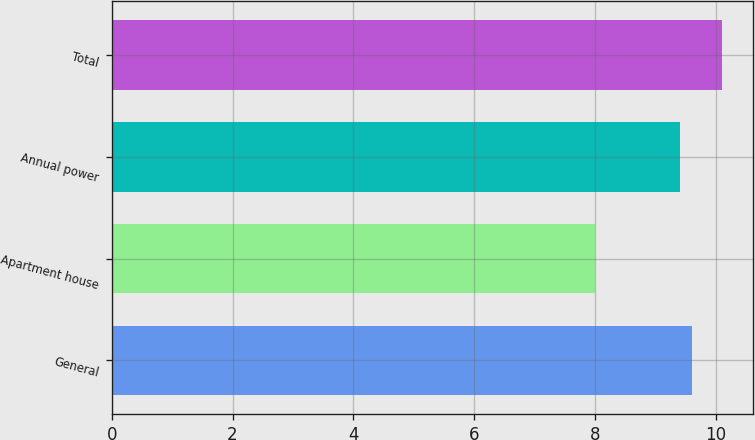Convert chart. <chart><loc_0><loc_0><loc_500><loc_500><bar_chart><fcel>General<fcel>Apartment house<fcel>Annual power<fcel>Total<nl><fcel>9.61<fcel>8<fcel>9.4<fcel>10.1<nl></chart> 